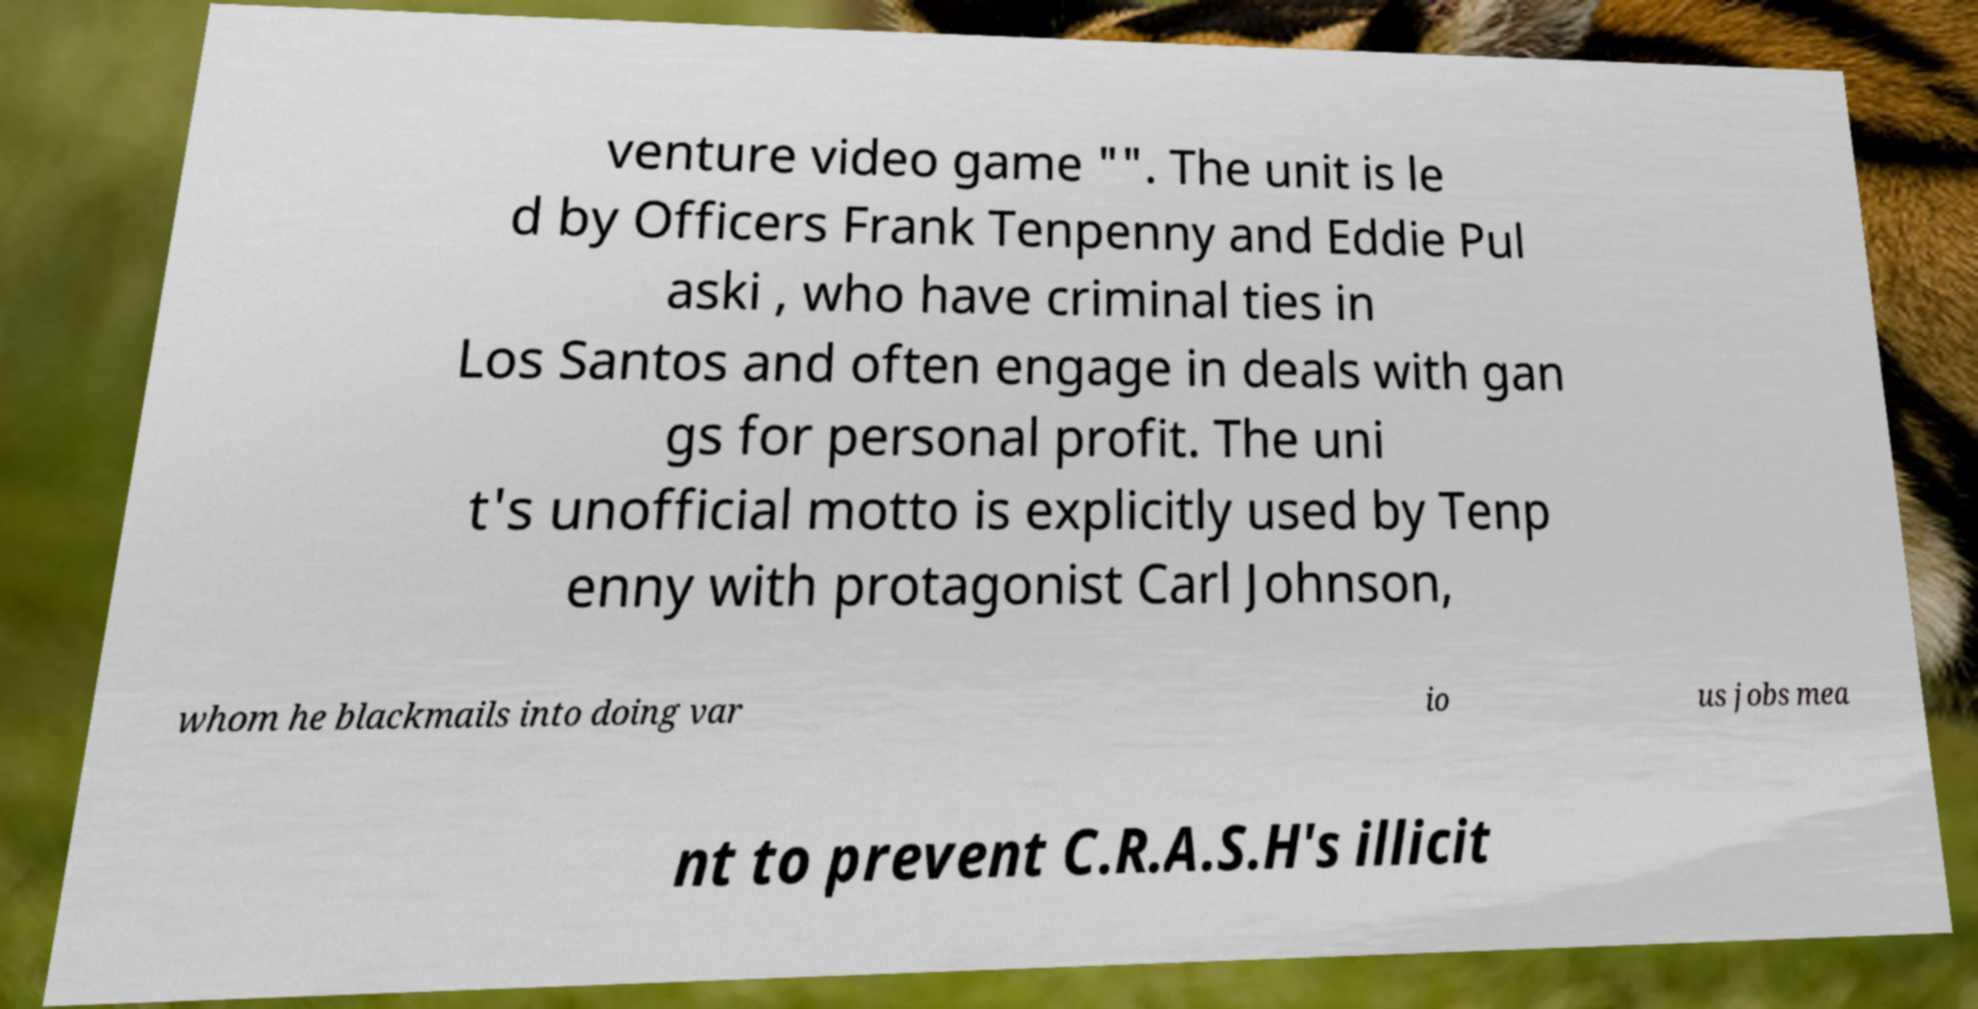Could you extract and type out the text from this image? venture video game "". The unit is le d by Officers Frank Tenpenny and Eddie Pul aski , who have criminal ties in Los Santos and often engage in deals with gan gs for personal profit. The uni t's unofficial motto is explicitly used by Tenp enny with protagonist Carl Johnson, whom he blackmails into doing var io us jobs mea nt to prevent C.R.A.S.H's illicit 